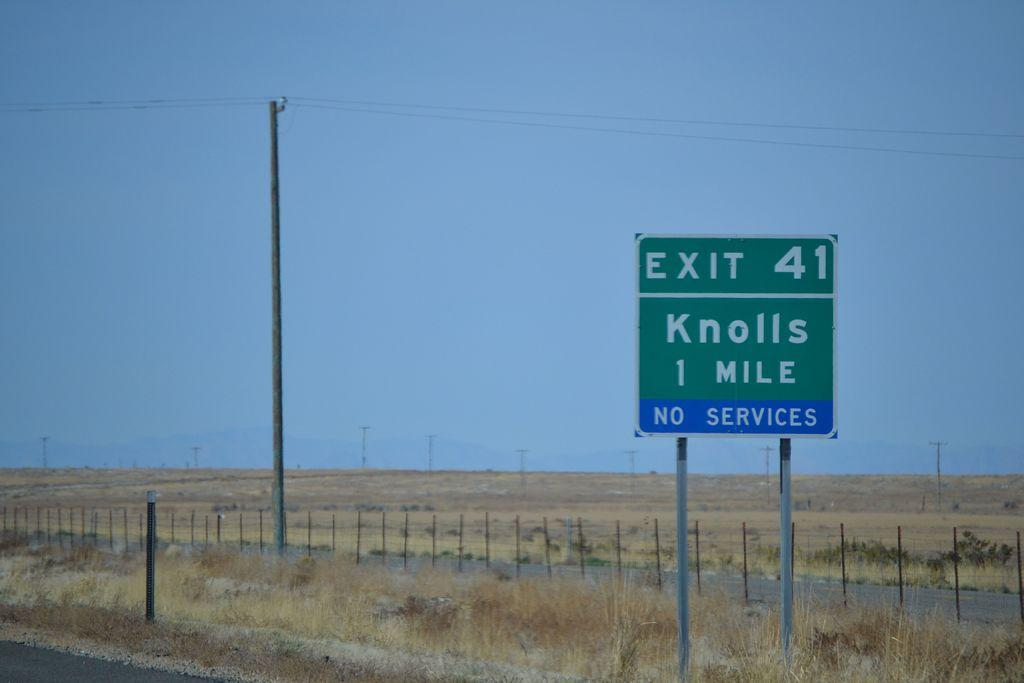<image>
Create a compact narrative representing the image presented. a knolls sign with exit 41 on it 